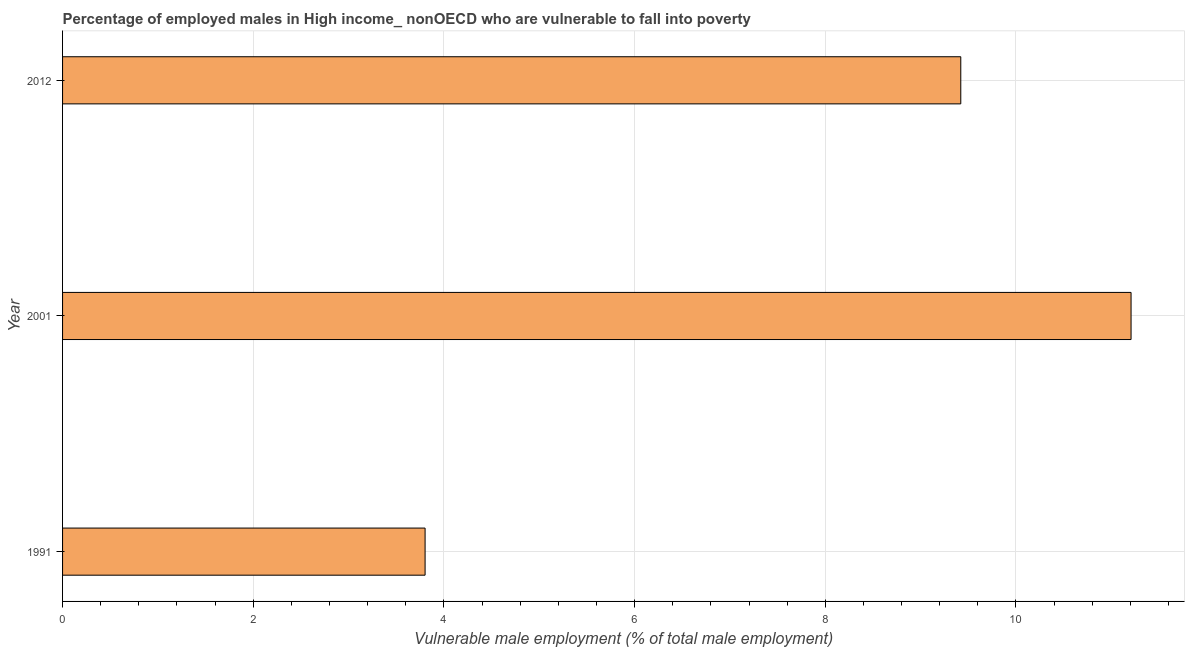What is the title of the graph?
Give a very brief answer. Percentage of employed males in High income_ nonOECD who are vulnerable to fall into poverty. What is the label or title of the X-axis?
Your response must be concise. Vulnerable male employment (% of total male employment). What is the percentage of employed males who are vulnerable to fall into poverty in 2012?
Your response must be concise. 9.42. Across all years, what is the maximum percentage of employed males who are vulnerable to fall into poverty?
Your answer should be compact. 11.21. Across all years, what is the minimum percentage of employed males who are vulnerable to fall into poverty?
Ensure brevity in your answer.  3.8. In which year was the percentage of employed males who are vulnerable to fall into poverty maximum?
Offer a very short reply. 2001. In which year was the percentage of employed males who are vulnerable to fall into poverty minimum?
Your response must be concise. 1991. What is the sum of the percentage of employed males who are vulnerable to fall into poverty?
Give a very brief answer. 24.43. What is the difference between the percentage of employed males who are vulnerable to fall into poverty in 1991 and 2012?
Your response must be concise. -5.62. What is the average percentage of employed males who are vulnerable to fall into poverty per year?
Your response must be concise. 8.14. What is the median percentage of employed males who are vulnerable to fall into poverty?
Your response must be concise. 9.42. Do a majority of the years between 1991 and 2012 (inclusive) have percentage of employed males who are vulnerable to fall into poverty greater than 10 %?
Keep it short and to the point. No. What is the ratio of the percentage of employed males who are vulnerable to fall into poverty in 1991 to that in 2001?
Your answer should be very brief. 0.34. Is the difference between the percentage of employed males who are vulnerable to fall into poverty in 2001 and 2012 greater than the difference between any two years?
Provide a short and direct response. No. What is the difference between the highest and the second highest percentage of employed males who are vulnerable to fall into poverty?
Keep it short and to the point. 1.79. What is the difference between the highest and the lowest percentage of employed males who are vulnerable to fall into poverty?
Your answer should be compact. 7.4. How many bars are there?
Give a very brief answer. 3. Are all the bars in the graph horizontal?
Provide a succinct answer. Yes. How many years are there in the graph?
Give a very brief answer. 3. What is the difference between two consecutive major ticks on the X-axis?
Make the answer very short. 2. Are the values on the major ticks of X-axis written in scientific E-notation?
Give a very brief answer. No. What is the Vulnerable male employment (% of total male employment) of 1991?
Make the answer very short. 3.8. What is the Vulnerable male employment (% of total male employment) in 2001?
Your answer should be very brief. 11.21. What is the Vulnerable male employment (% of total male employment) of 2012?
Offer a terse response. 9.42. What is the difference between the Vulnerable male employment (% of total male employment) in 1991 and 2001?
Give a very brief answer. -7.4. What is the difference between the Vulnerable male employment (% of total male employment) in 1991 and 2012?
Keep it short and to the point. -5.62. What is the difference between the Vulnerable male employment (% of total male employment) in 2001 and 2012?
Give a very brief answer. 1.79. What is the ratio of the Vulnerable male employment (% of total male employment) in 1991 to that in 2001?
Your response must be concise. 0.34. What is the ratio of the Vulnerable male employment (% of total male employment) in 1991 to that in 2012?
Provide a short and direct response. 0.4. What is the ratio of the Vulnerable male employment (% of total male employment) in 2001 to that in 2012?
Provide a short and direct response. 1.19. 